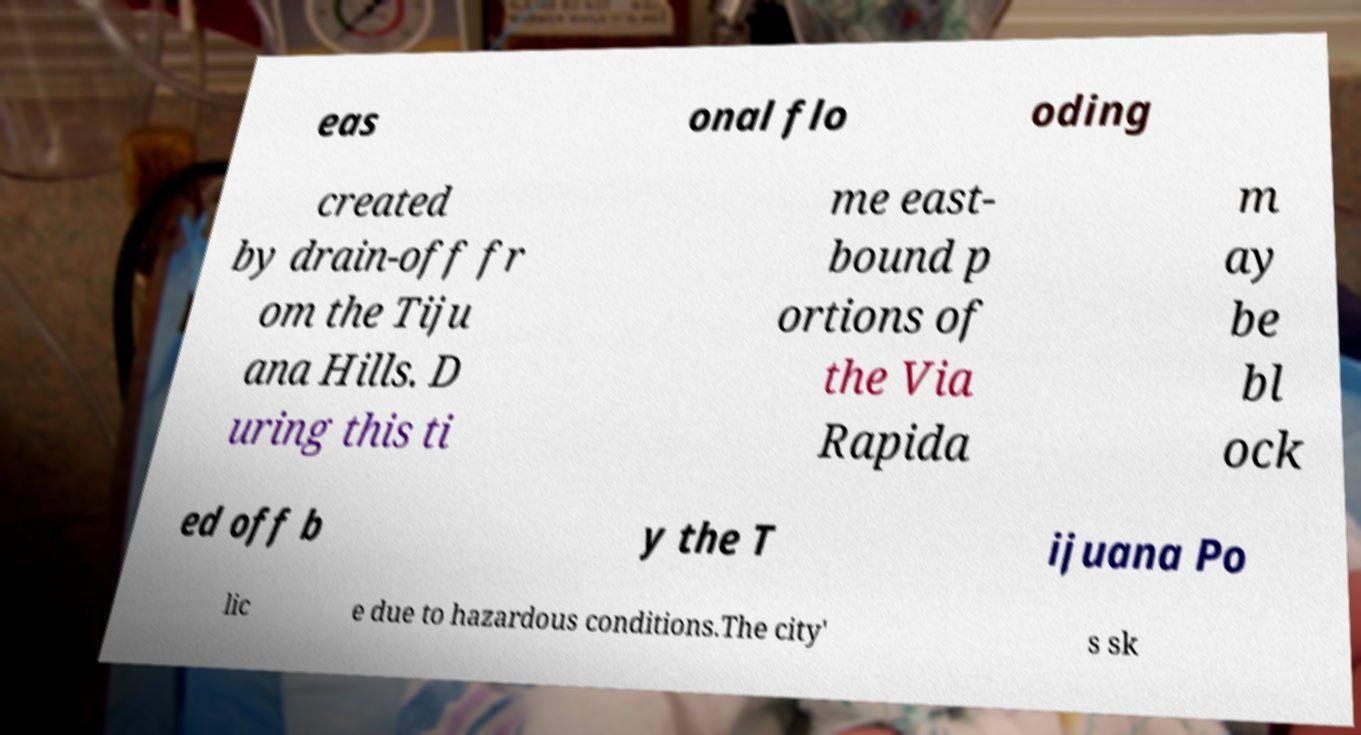Can you accurately transcribe the text from the provided image for me? eas onal flo oding created by drain-off fr om the Tiju ana Hills. D uring this ti me east- bound p ortions of the Via Rapida m ay be bl ock ed off b y the T ijuana Po lic e due to hazardous conditions.The city' s sk 